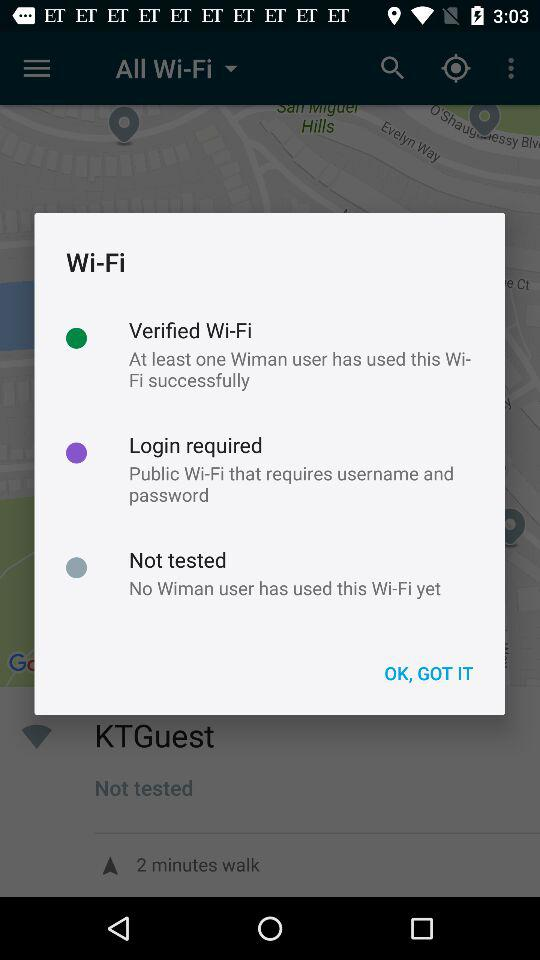How many "Wiman" users have used the Wi-Fi? There are no "Wiman" users who have used the Wi-Fi. 